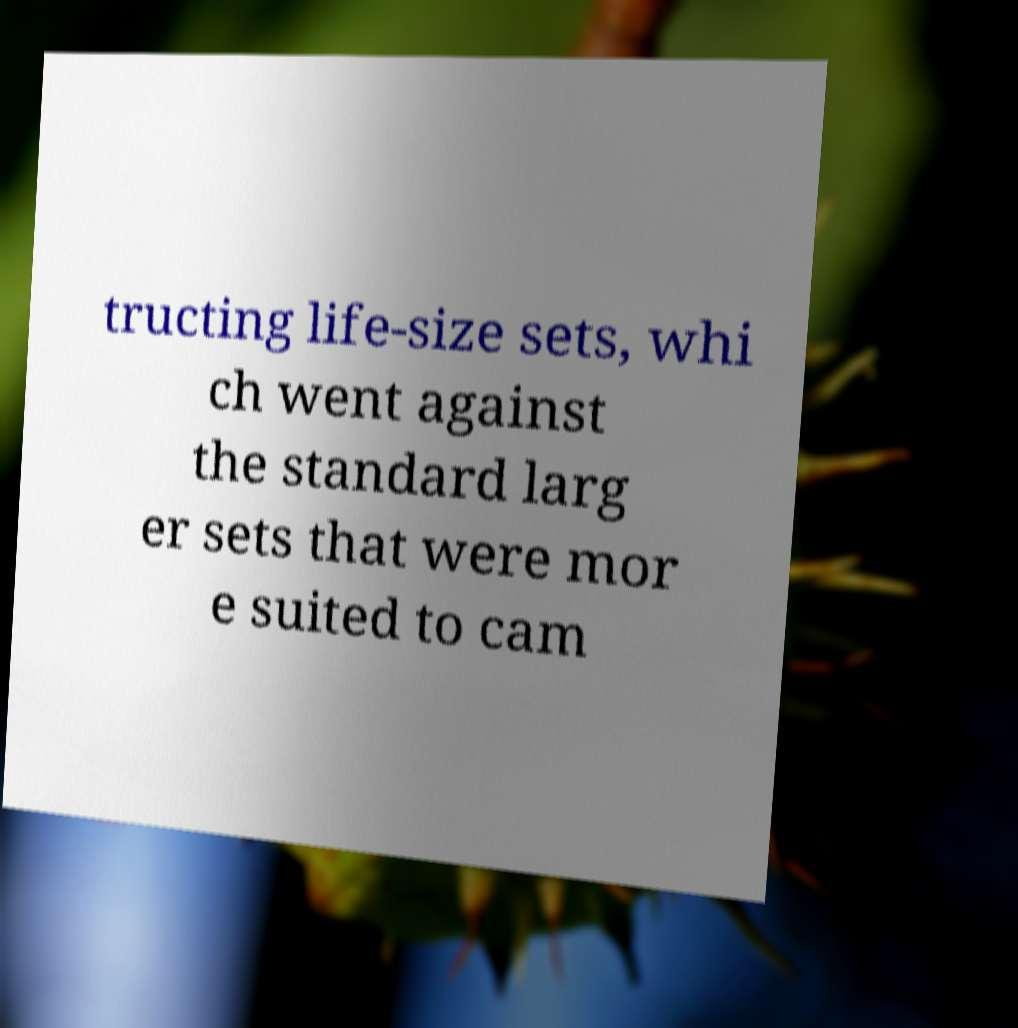Could you assist in decoding the text presented in this image and type it out clearly? tructing life-size sets, whi ch went against the standard larg er sets that were mor e suited to cam 